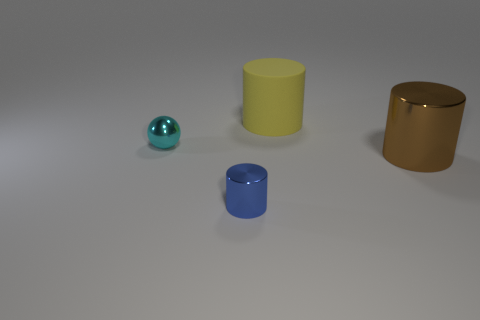Subtract all cylinders. How many objects are left? 1 Add 1 tiny brown metallic objects. How many objects exist? 5 Subtract all large brown metal things. Subtract all blue cylinders. How many objects are left? 2 Add 1 blue cylinders. How many blue cylinders are left? 2 Add 1 blue metal cylinders. How many blue metal cylinders exist? 2 Subtract 0 yellow blocks. How many objects are left? 4 